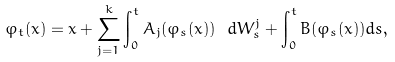Convert formula to latex. <formula><loc_0><loc_0><loc_500><loc_500>\varphi _ { t } ( x ) = x + \sum _ { j = 1 } ^ { k } \int _ { 0 } ^ { t } A _ { j } ( \varphi _ { s } ( x ) ) \ d W _ { s } ^ { j } + \int _ { 0 } ^ { t } B ( \varphi _ { s } ( x ) ) d s ,</formula> 